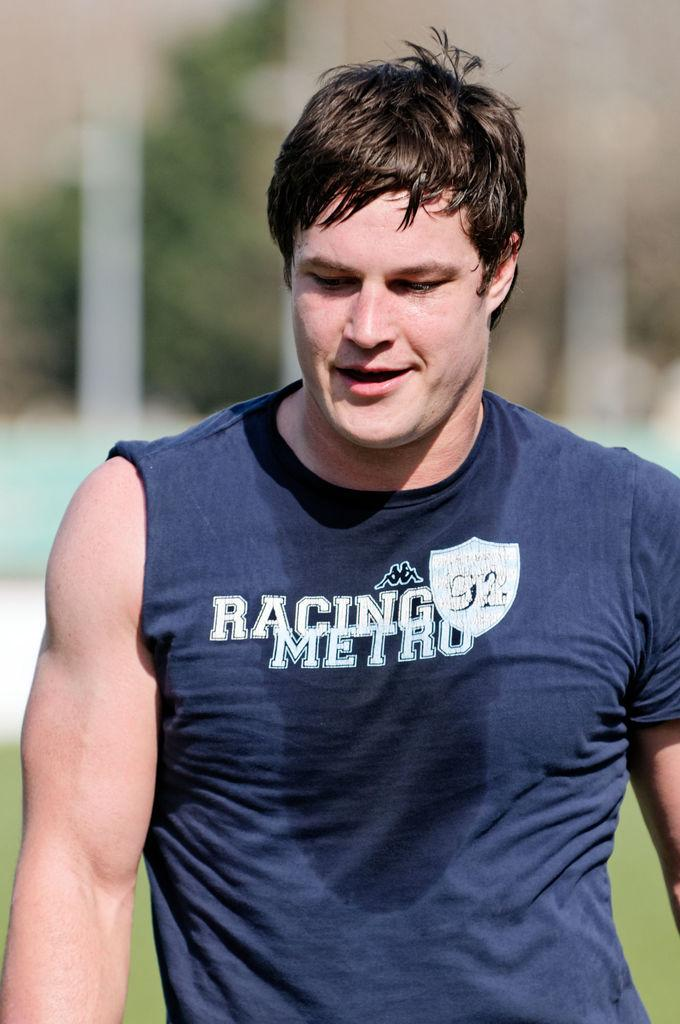<image>
Relay a brief, clear account of the picture shown. A sweaty man in a one sleeved shirt that says Racing Metro 